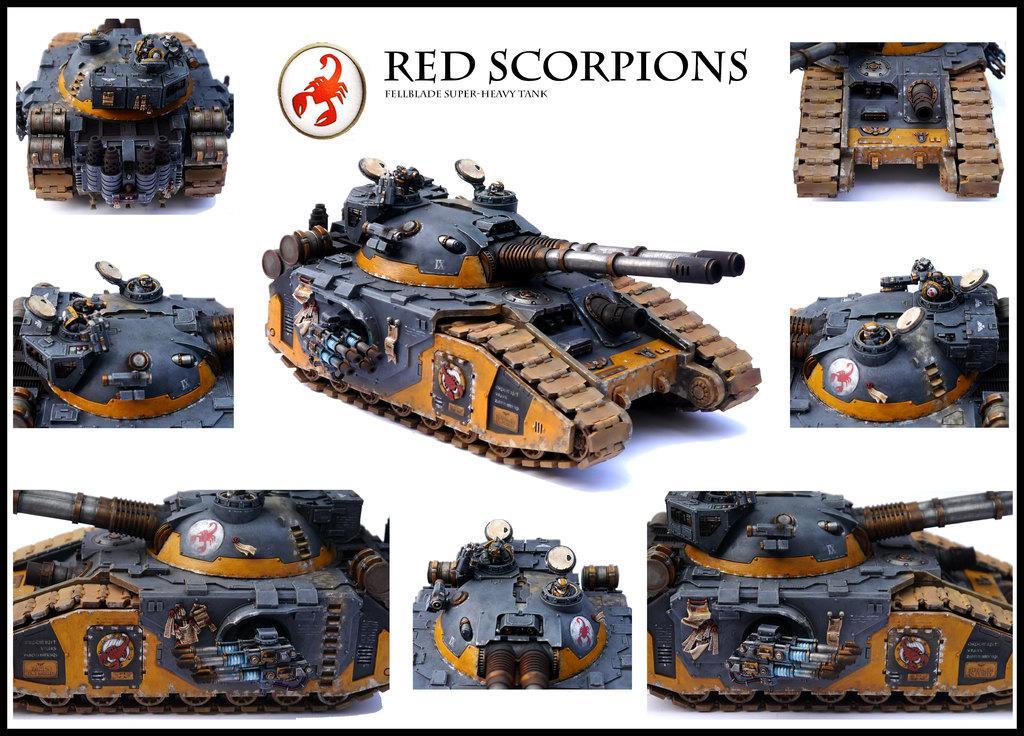Describe this image in one or two sentences. On this poster there are pictures of military vehicles. This is a logo. Something written on this poster. 